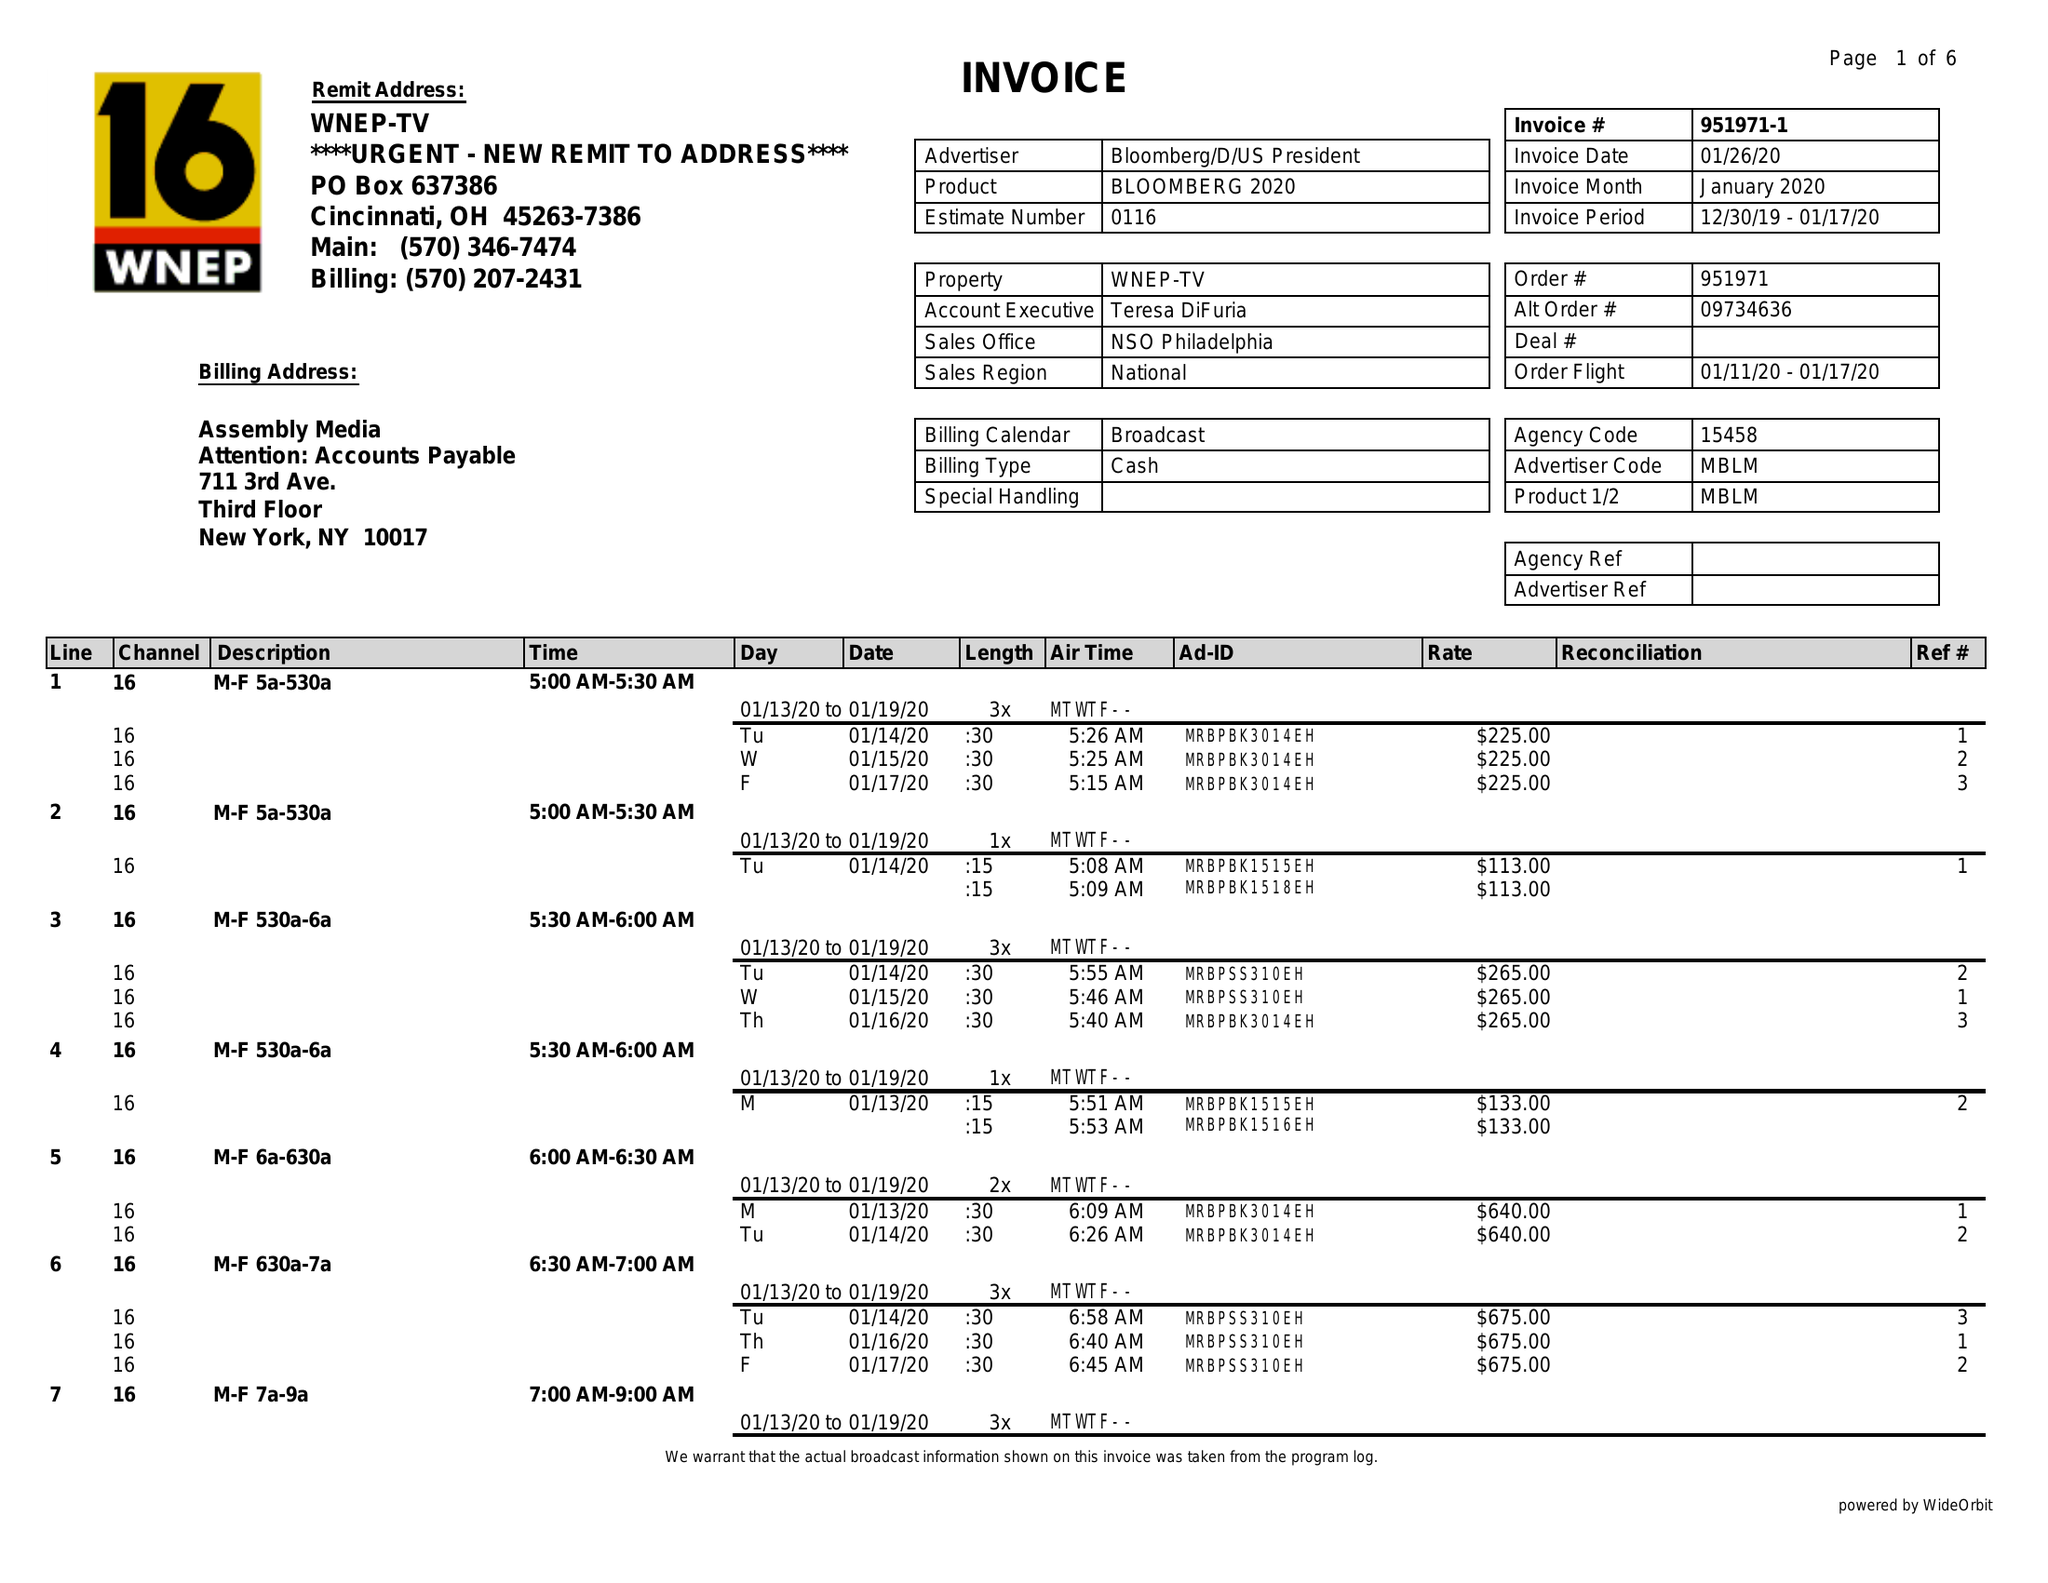What is the value for the advertiser?
Answer the question using a single word or phrase. BLOOMBERG/D/USPRESIDENT 